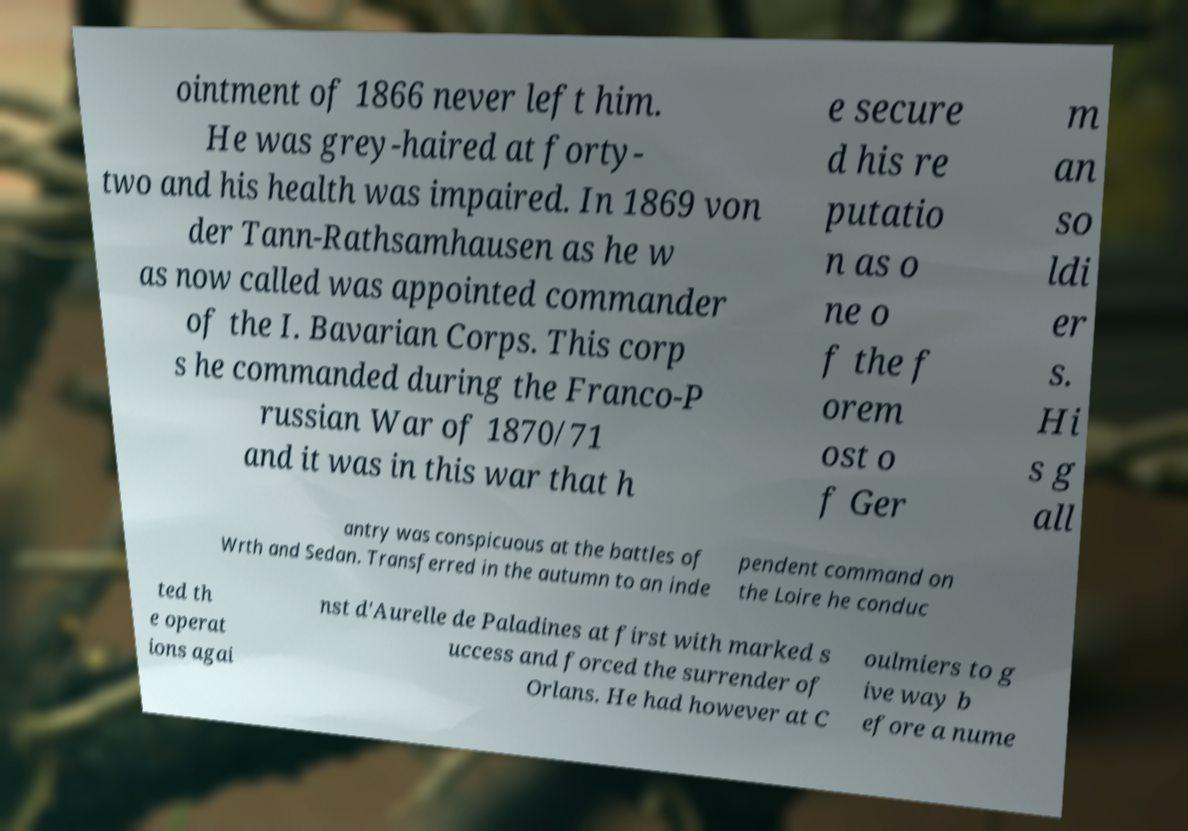Can you read and provide the text displayed in the image?This photo seems to have some interesting text. Can you extract and type it out for me? ointment of 1866 never left him. He was grey-haired at forty- two and his health was impaired. In 1869 von der Tann-Rathsamhausen as he w as now called was appointed commander of the I. Bavarian Corps. This corp s he commanded during the Franco-P russian War of 1870/71 and it was in this war that h e secure d his re putatio n as o ne o f the f orem ost o f Ger m an so ldi er s. Hi s g all antry was conspicuous at the battles of Wrth and Sedan. Transferred in the autumn to an inde pendent command on the Loire he conduc ted th e operat ions agai nst d'Aurelle de Paladines at first with marked s uccess and forced the surrender of Orlans. He had however at C oulmiers to g ive way b efore a nume 